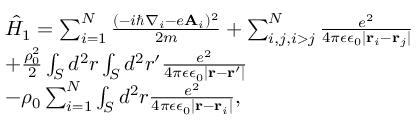<formula> <loc_0><loc_0><loc_500><loc_500>\begin{array} { l } { \hat { H } _ { 1 } = \sum _ { i = 1 } ^ { N } \frac { ( - i \hbar { \nabla } _ { i } - e A _ { i } ) ^ { 2 } } { 2 m } + \sum _ { i , j , i > j } ^ { N } \frac { e ^ { 2 } } { 4 \pi \epsilon \epsilon _ { 0 } | r _ { i } - r _ { j } | } } \\ { + \frac { \rho _ { 0 } ^ { 2 } } { 2 } \int _ { S } d ^ { 2 } r \int _ { S } d ^ { 2 } r ^ { \prime } \frac { e ^ { 2 } } { 4 \pi \epsilon \epsilon _ { 0 } | r - r ^ { \prime } | } } \\ { - \rho _ { 0 } \sum _ { i = 1 } ^ { N } \int _ { S } d ^ { 2 } r \frac { e ^ { 2 } } { 4 \pi \epsilon \epsilon _ { 0 } | r - r _ { i } | } , } \end{array}</formula> 